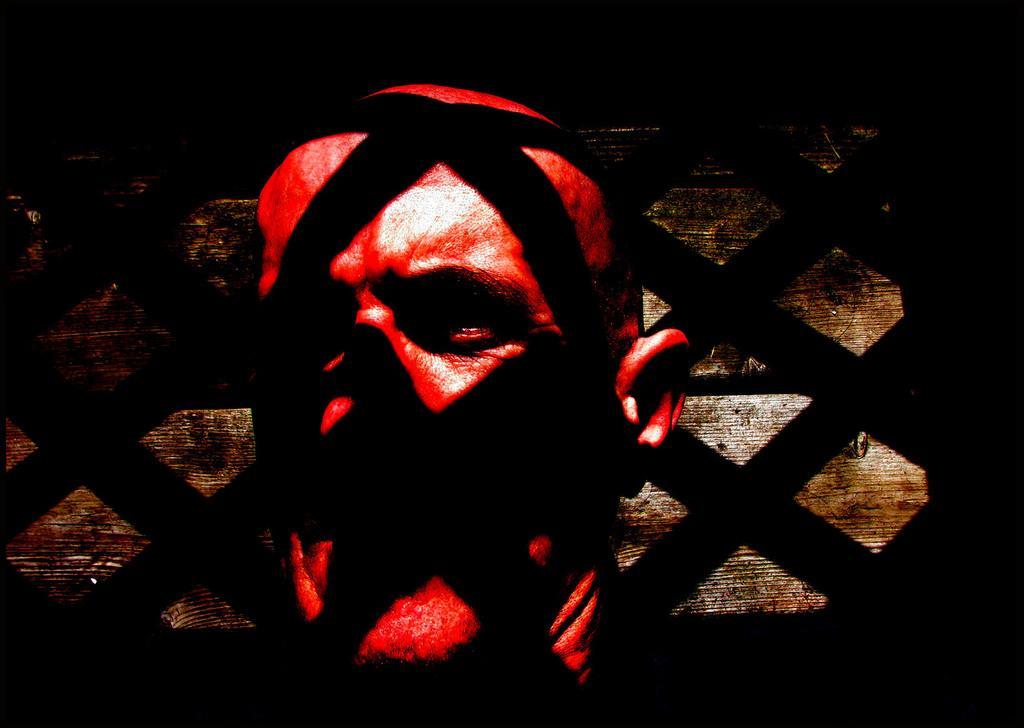Please provide a concise description of this image. In the image there is a face of a person with red paint and there is some black shadow falling on the face of the person. 